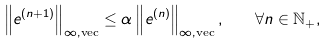<formula> <loc_0><loc_0><loc_500><loc_500>\left \| e ^ { ( n + 1 ) } \right \| _ { \infty , \text {vec} } \leq \alpha \left \| e ^ { ( n ) } \right \| _ { \infty , \text {vec} } , \quad \forall n \in \mathbb { N } _ { + } ,</formula> 